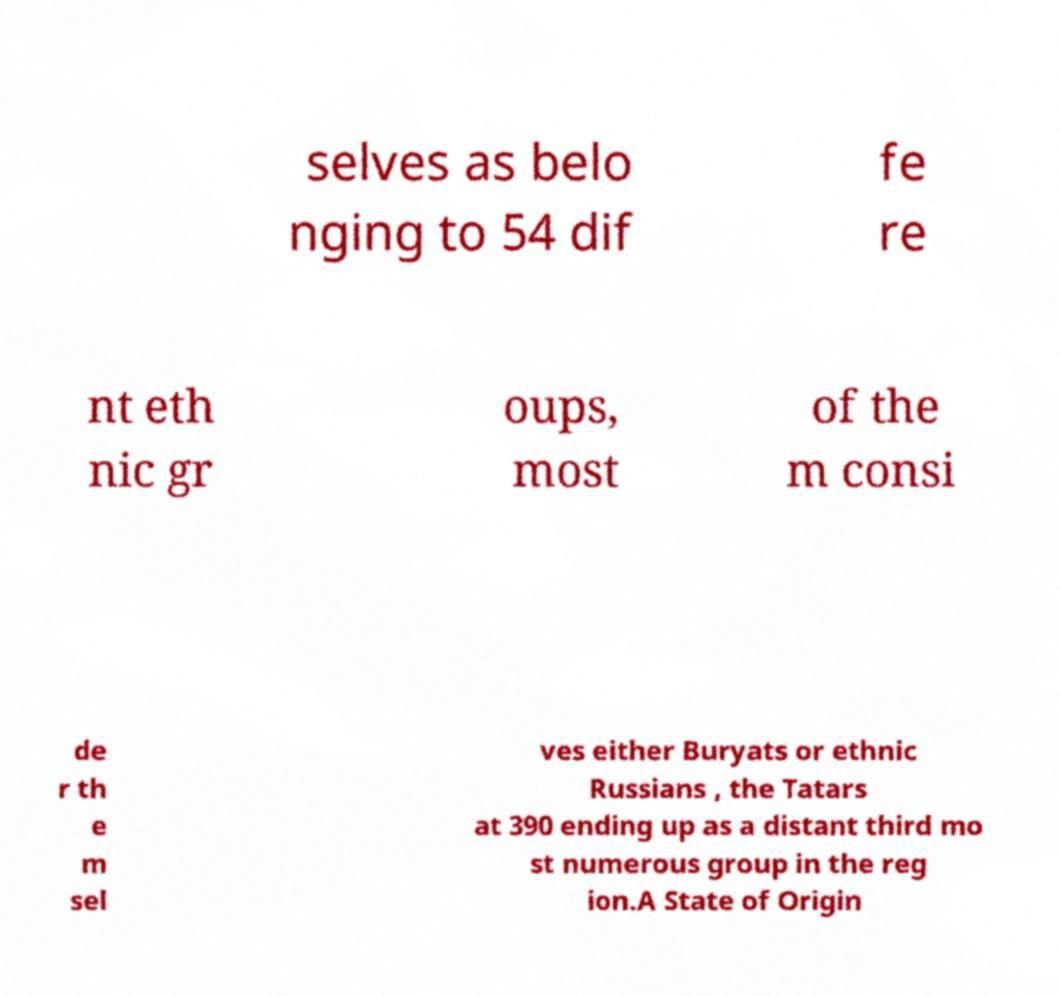Could you assist in decoding the text presented in this image and type it out clearly? selves as belo nging to 54 dif fe re nt eth nic gr oups, most of the m consi de r th e m sel ves either Buryats or ethnic Russians , the Tatars at 390 ending up as a distant third mo st numerous group in the reg ion.A State of Origin 